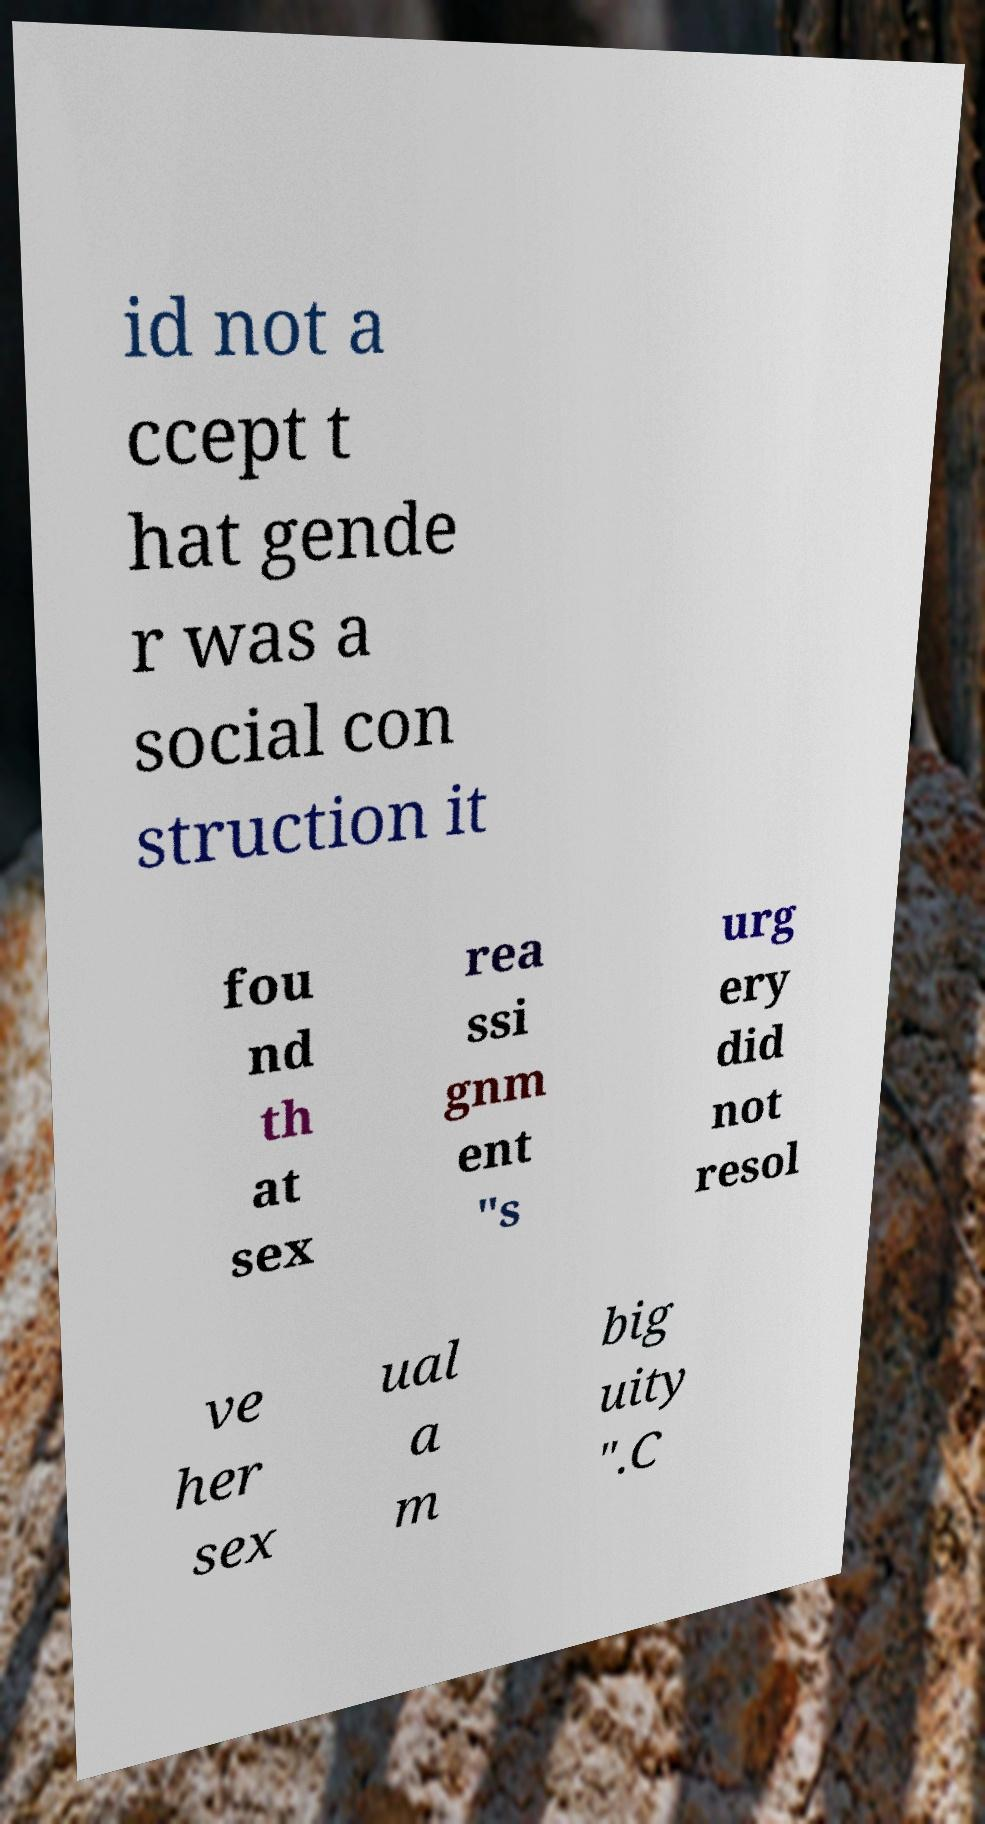What messages or text are displayed in this image? I need them in a readable, typed format. id not a ccept t hat gende r was a social con struction it fou nd th at sex rea ssi gnm ent "s urg ery did not resol ve her sex ual a m big uity ".C 